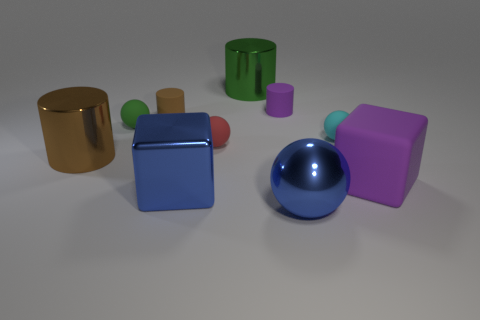Subtract all spheres. How many objects are left? 6 Add 1 tiny green rubber objects. How many tiny green rubber objects are left? 2 Add 5 tiny cyan shiny things. How many tiny cyan shiny things exist? 5 Subtract 0 purple spheres. How many objects are left? 10 Subtract all tiny blue rubber cylinders. Subtract all large blue metallic cubes. How many objects are left? 9 